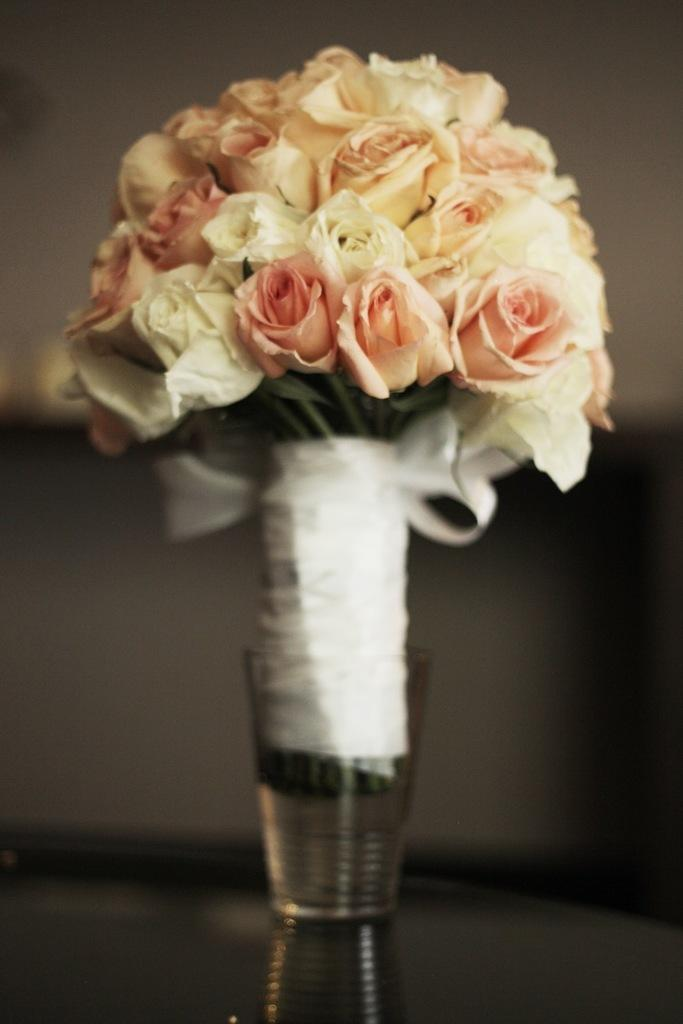What is the main subject of the image? The main subject of the image is a flower bouquet. Are there any additional features on the bouquet? Yes, the bouquet has a ribbon. How is the bouquet displayed in the image? The bouquet is in a glass. Can you describe the background of the image? The background of the image is blurry. What type of protest is taking place in the image? There is no protest present in the image; it features a flower bouquet in a glass with a ribbon. What kind of flesh can be seen in the image? There is no flesh present in the image; it only contains a flower bouquet. 